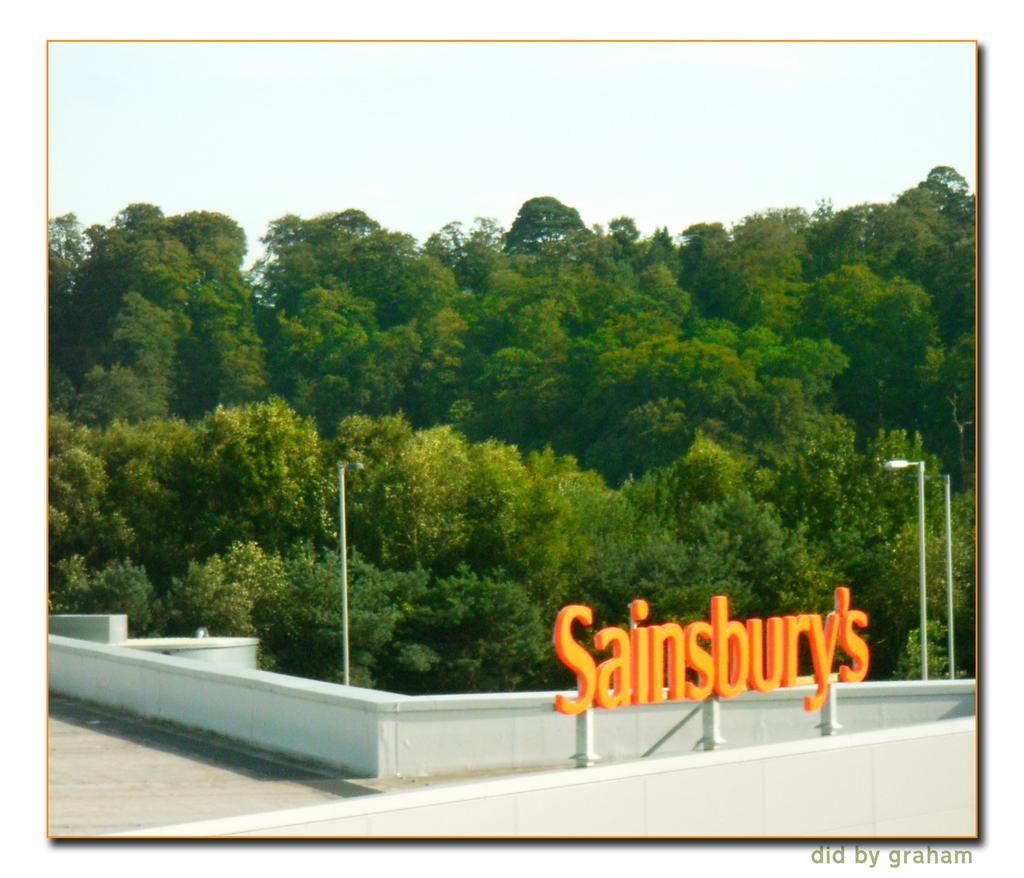What is the main subject of the image? The main subject of the image is a place. What can be seen around the place in the image? The place is surrounded by green trees. What type of silk fabric is draped over the wrist of the person in the image? There is no person present in the image, and therefore no wrist or silk fabric can be observed. 